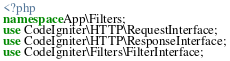Convert code to text. <code><loc_0><loc_0><loc_500><loc_500><_PHP_><?php
namespace App\Filters;
use CodeIgniter\HTTP\RequestInterface;
use CodeIgniter\HTTP\ResponseInterface;
use CodeIgniter\Filters\FilterInterface;</code> 